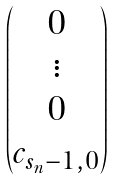Convert formula to latex. <formula><loc_0><loc_0><loc_500><loc_500>\begin{pmatrix} 0 \\ \vdots \\ 0 \\ c _ { s _ { n } - 1 , 0 } \\ \end{pmatrix}</formula> 